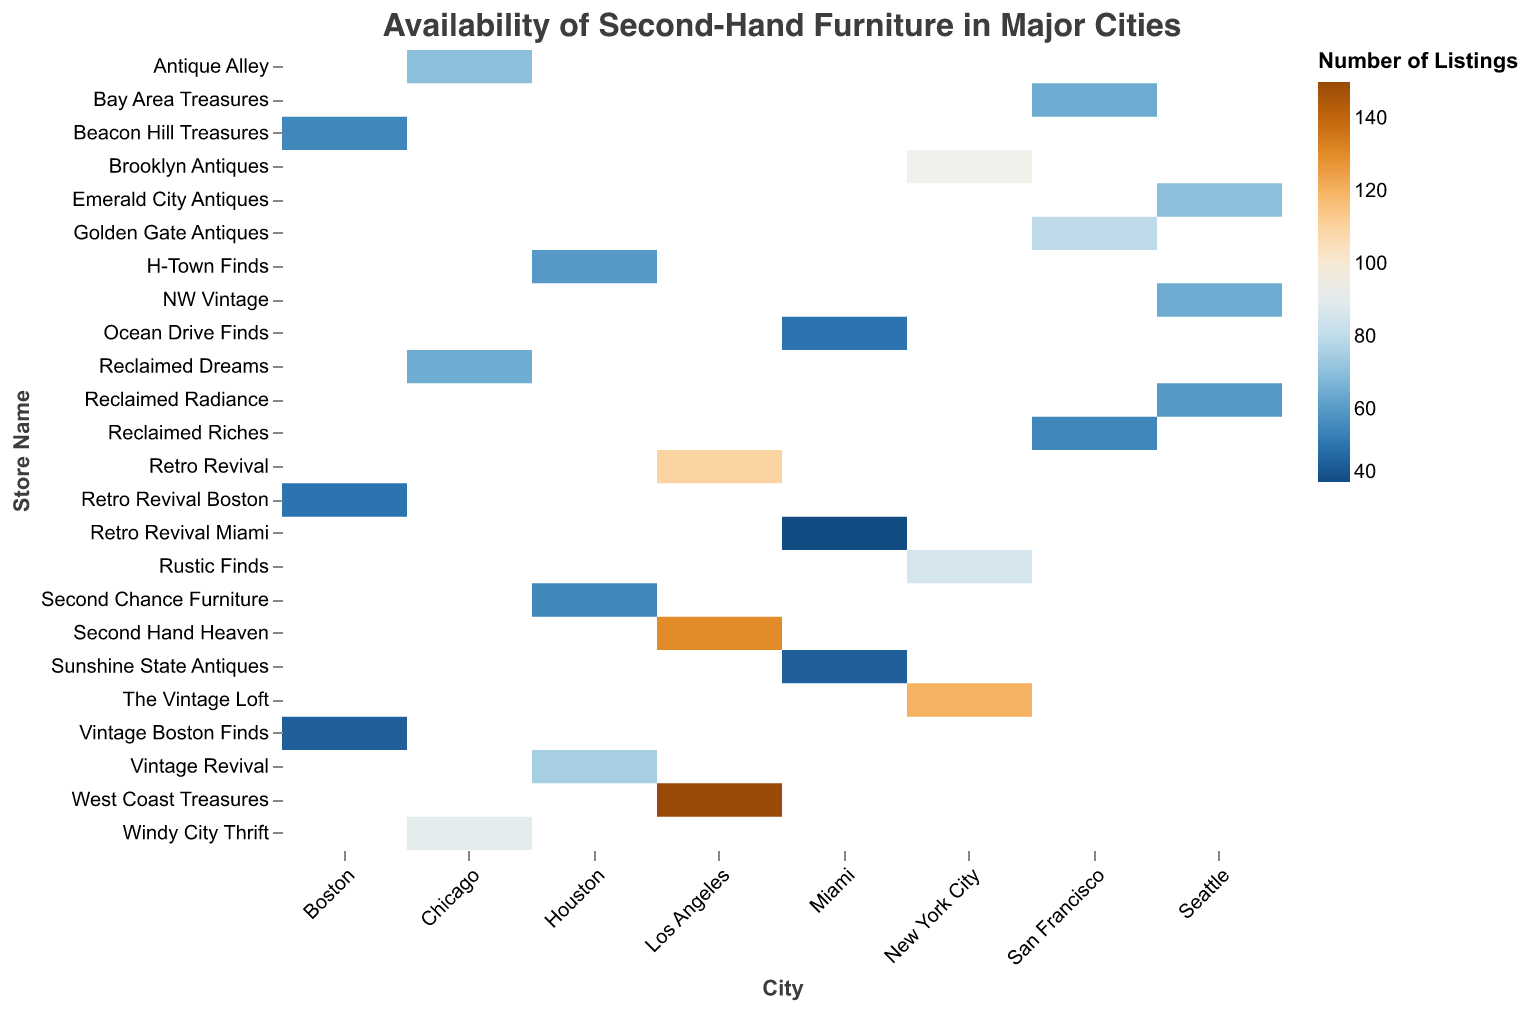Which city hosts the store with the highest number of listings? The store with the highest number of listings is "West Coast Treasures" in Los Angeles, which can be seen by identifying the darkest cell on the heatmap.
Answer: Los Angeles How many stores in San Francisco have more than 70 listings? By looking at the cells corresponding to San Francisco, only "Golden Gate Antiques" has listings greater than 70, totaling one store.
Answer: 1 Which city has the store with the lowest number of listings? The store "Retro Revival Miami" in Miami has the lowest number of listings, indicated by the lightest cell on the heatmap.
Answer: Miami What is the total number of listings for second-hand furniture stores in Chicago? The listings in Chicago are 90 for "Windy City Thrift," 70 for "Antique Alley," and 65 for "Reclaimed Dreams." Summing them up: 90 + 70 + 65 = 225.
Answer: 225 How does the availability of listings in New York City compare to that in Miami? To compare, note the total listings in New York City (120 + 85 + 95 = 300) and Miami (45 + 50 + 40 = 135). New York City has more listings than Miami.
Answer: New York City has more What is the average number of listings per store in Los Angeles? The listings in Los Angeles are 150, 110, and 130. Summing them and dividing by the number of stores: (150 + 110 + 130) / 3 = 130.
Answer: 130 How many stores in Boston have listings between 40 and 60? By examining the heatmap, all three stores in Boston ("Beacon Hill Treasures," "Retro Revival Boston," and "Vintage Boston Finds") fall within the 40-60 range.
Answer: 3 Which store in New York City has the second most listings? In New York City, "Brooklyn Antiques" has 95 listings, which is the second highest after "The Vintage Loft."
Answer: Brooklyn Antiques 